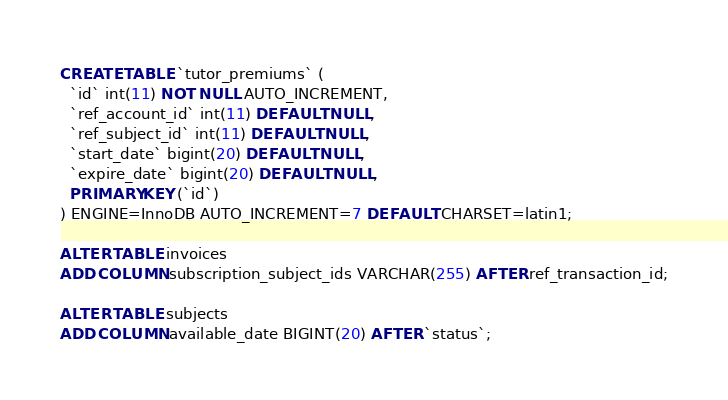Convert code to text. <code><loc_0><loc_0><loc_500><loc_500><_SQL_>CREATE TABLE `tutor_premiums` (
  `id` int(11) NOT NULL AUTO_INCREMENT,
  `ref_account_id` int(11) DEFAULT NULL,
  `ref_subject_id` int(11) DEFAULT NULL,
  `start_date` bigint(20) DEFAULT NULL,
  `expire_date` bigint(20) DEFAULT NULL,
  PRIMARY KEY (`id`)
) ENGINE=InnoDB AUTO_INCREMENT=7 DEFAULT CHARSET=latin1;

ALTER TABLE invoices 
ADD COLUMN subscription_subject_ids VARCHAR(255) AFTER ref_transaction_id;

ALTER TABLE subjects 
ADD COLUMN available_date BIGINT(20) AFTER `status`;
</code> 